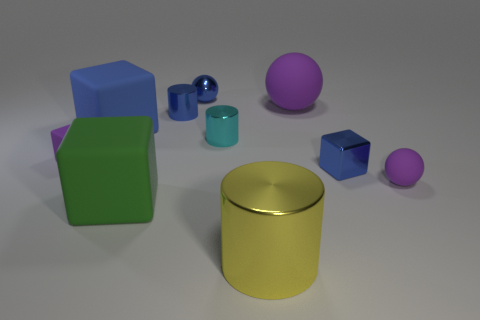Subtract all cylinders. How many objects are left? 7 Add 1 big green matte things. How many big green matte things are left? 2 Add 1 blue metal things. How many blue metal things exist? 4 Subtract 0 gray balls. How many objects are left? 10 Subtract all large blue cylinders. Subtract all small cylinders. How many objects are left? 8 